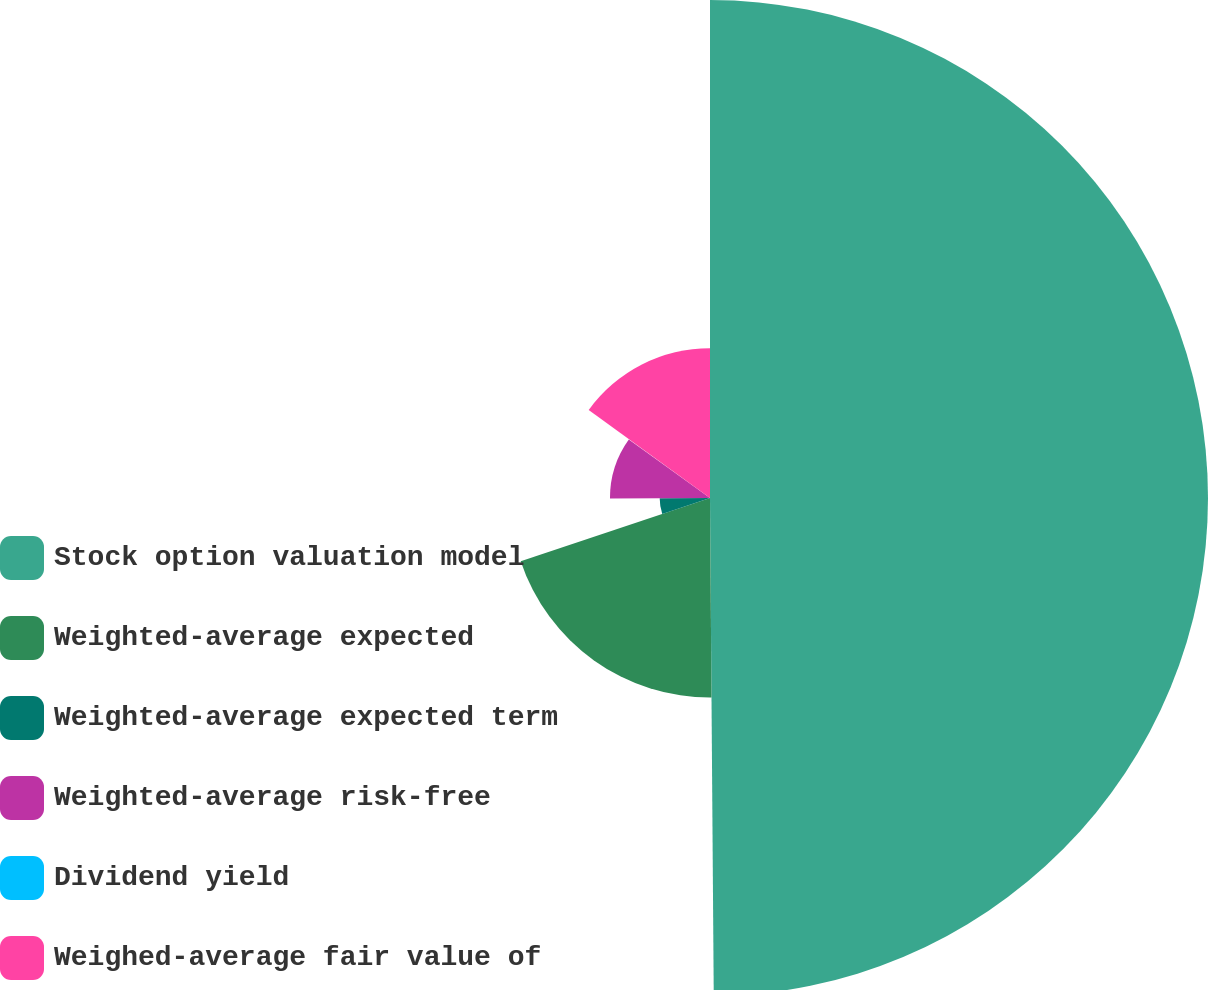Convert chart to OTSL. <chart><loc_0><loc_0><loc_500><loc_500><pie_chart><fcel>Stock option valuation model<fcel>Weighted-average expected<fcel>Weighted-average expected term<fcel>Weighted-average risk-free<fcel>Dividend yield<fcel>Weighed-average fair value of<nl><fcel>49.88%<fcel>19.99%<fcel>5.04%<fcel>10.02%<fcel>0.06%<fcel>15.01%<nl></chart> 